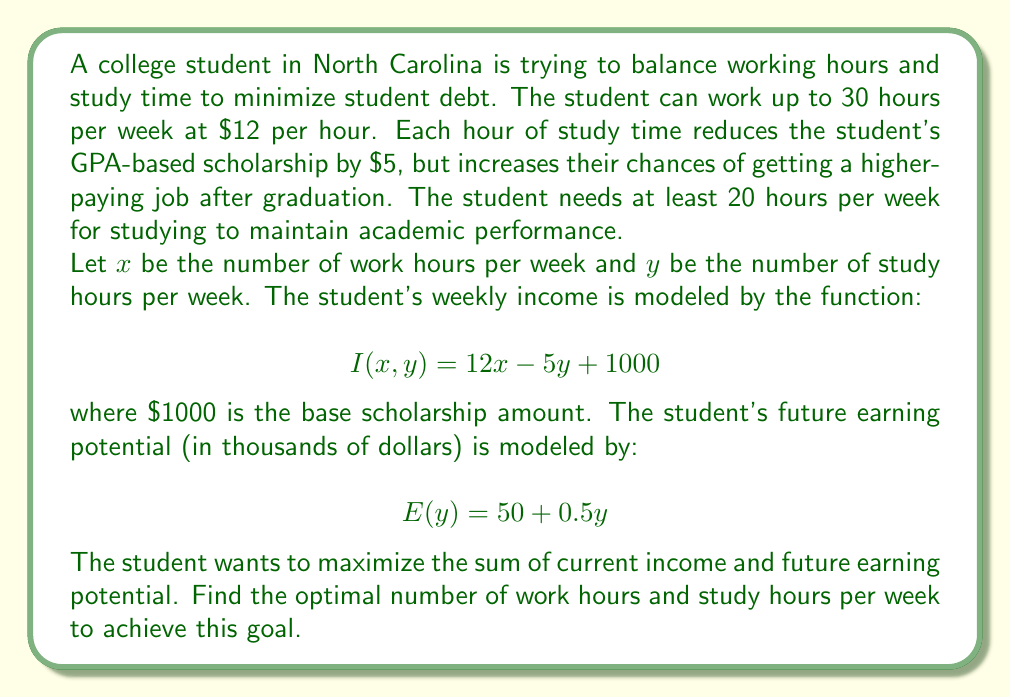What is the answer to this math problem? To solve this optimization problem, we need to:

1. Define the objective function
2. Identify constraints
3. Set up the optimization problem
4. Solve using the method of Lagrange multipliers

Step 1: Define the objective function

We want to maximize the sum of current income and future earning potential:

$$F(x,y) = I(x,y) + E(y) = (12x - 5y + 1000) + (50 + 0.5y) = 12x - 4.5y + 1050$$

Step 2: Identify constraints

- Work hours: $0 \leq x \leq 30$
- Study hours: $y \geq 20$
- Total hours: $x + y \leq 168$ (24 hours * 7 days)

Step 3: Set up the optimization problem

Maximize $F(x,y) = 12x - 4.5y + 1050$ subject to:
- $g_1(x,y) = x + y - 168 \leq 0$
- $g_2(x) = x - 30 \leq 0$
- $g_3(x) = -x \leq 0$
- $g_4(y) = 20 - y \leq 0$

Step 4: Solve using the method of Lagrange multipliers

The Lagrangian function is:

$$L(x,y,\lambda_1,\lambda_2,\lambda_3,\lambda_4) = 12x - 4.5y + 1050 - \lambda_1(x+y-168) - \lambda_2(x-30) + \lambda_3x + \lambda_4(y-20)$$

Setting partial derivatives to zero:

$$\frac{\partial L}{\partial x} = 12 - \lambda_1 - \lambda_2 + \lambda_3 = 0$$
$$\frac{\partial L}{\partial y} = -4.5 - \lambda_1 + \lambda_4 = 0$$

Complementary slackness conditions:

$$\lambda_1(x+y-168) = 0$$
$$\lambda_2(x-30) = 0$$
$$\lambda_3x = 0$$
$$\lambda_4(y-20) = 0$$

Solving this system of equations, we find that the optimal solution occurs at the corner point $(x,y) = (30,20)$, where the student works the maximum allowed hours and studies the minimum required hours.
Answer: The optimal balance is to work 30 hours per week and study 20 hours per week, maximizing the objective function at $F(30,20) = 1410$. 